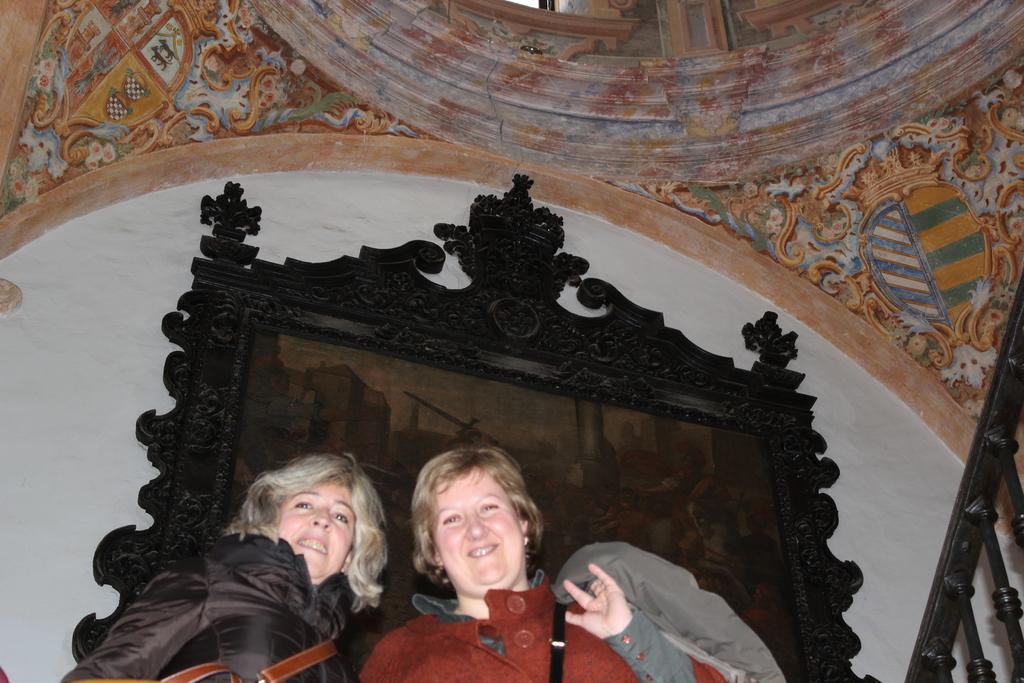Could you give a brief overview of what you see in this image? In this image I can see two people standing and wearing the different color dresses. To the back of these people I can see the black color frame to the wall. And these people are inside the building. In the back I can see the colorful wall. 